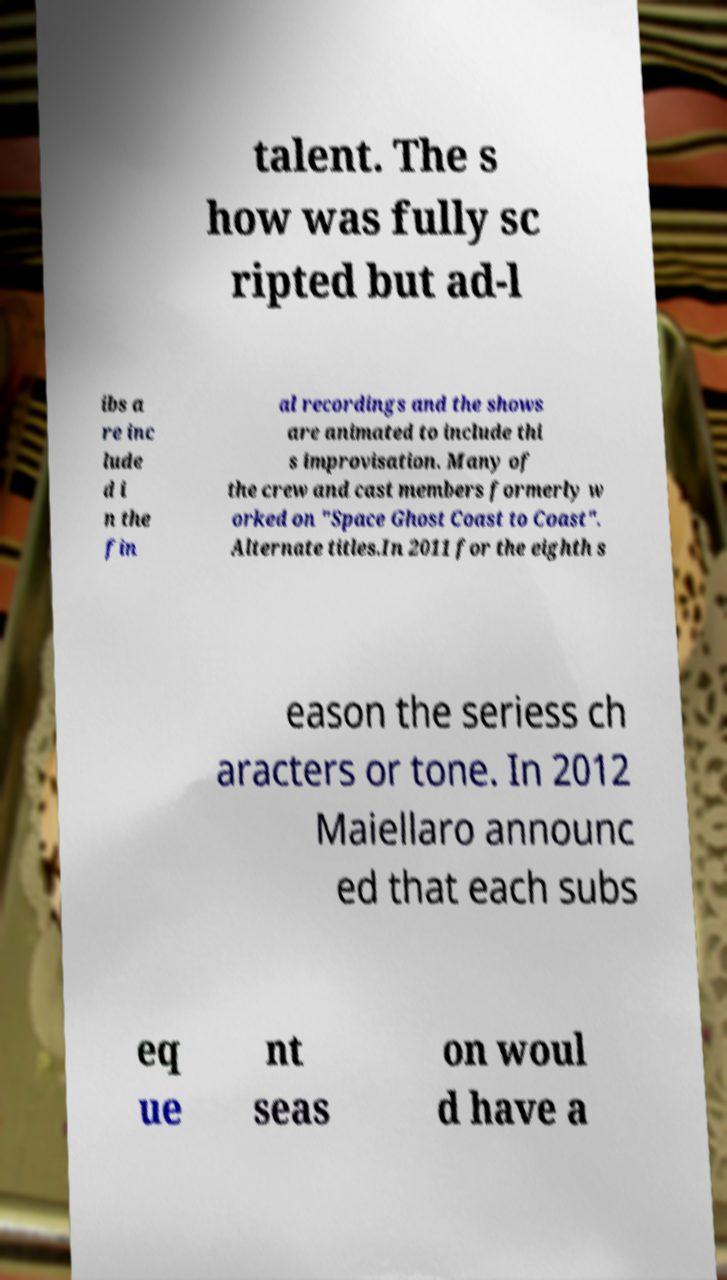Please read and relay the text visible in this image. What does it say? talent. The s how was fully sc ripted but ad-l ibs a re inc lude d i n the fin al recordings and the shows are animated to include thi s improvisation. Many of the crew and cast members formerly w orked on "Space Ghost Coast to Coast". Alternate titles.In 2011 for the eighth s eason the seriess ch aracters or tone. In 2012 Maiellaro announc ed that each subs eq ue nt seas on woul d have a 